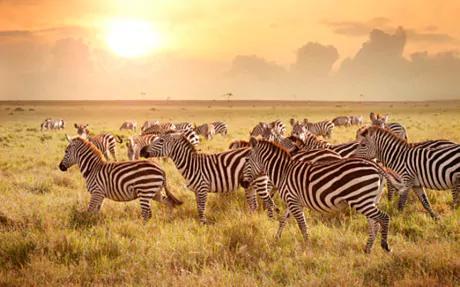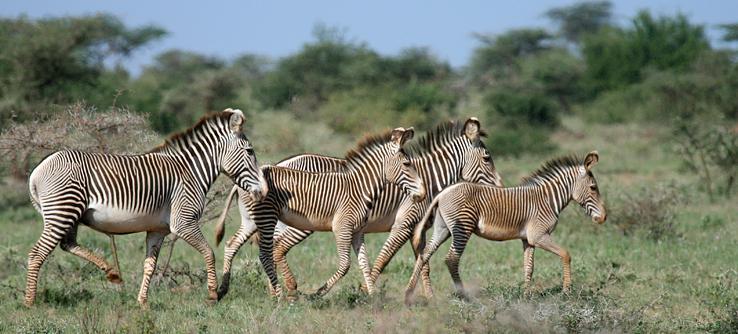The first image is the image on the left, the second image is the image on the right. Given the left and right images, does the statement "There are three zebras standing side by side in a line and looking straight ahead in one of the images." hold true? Answer yes or no. No. The first image is the image on the left, the second image is the image on the right. Given the left and right images, does the statement "One image has a trio of zebras standing with bodies turned forward and gazing straight at the camera, in the foreground." hold true? Answer yes or no. No. 